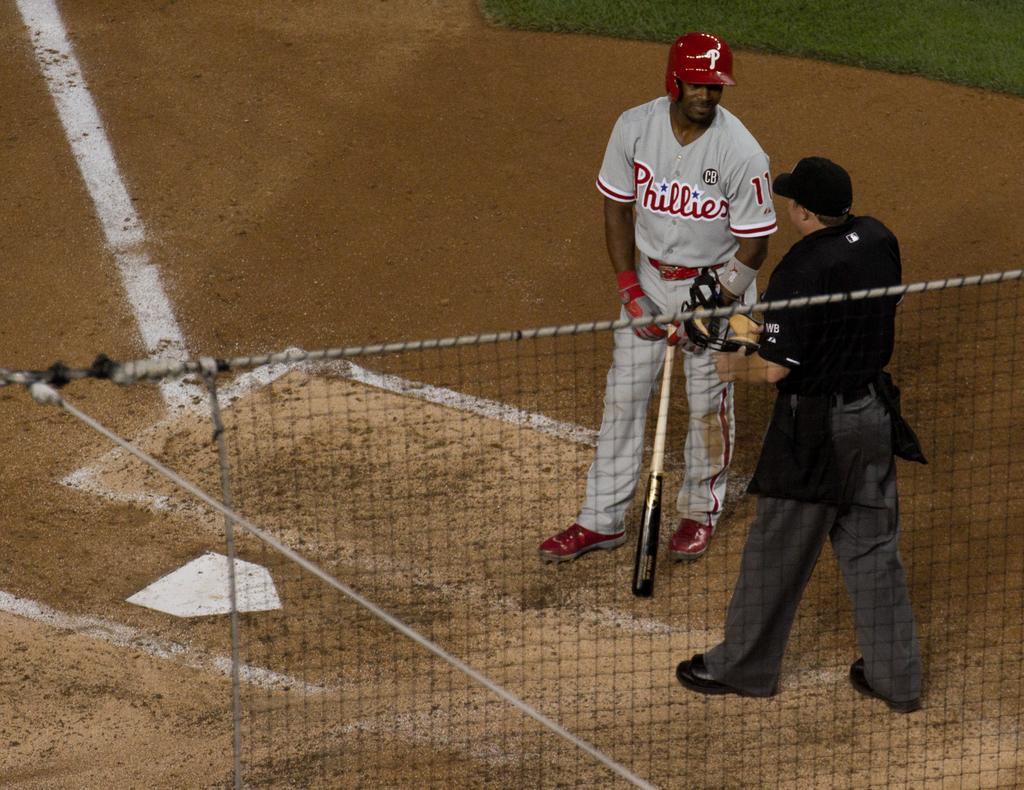Describe this image in one or two sentences. In this image there is a person standing and holding a baseball bat, beside him there is a person standing on the ground, in the foreground of the image there is a net. In the background, we can see the surface of the grass. 